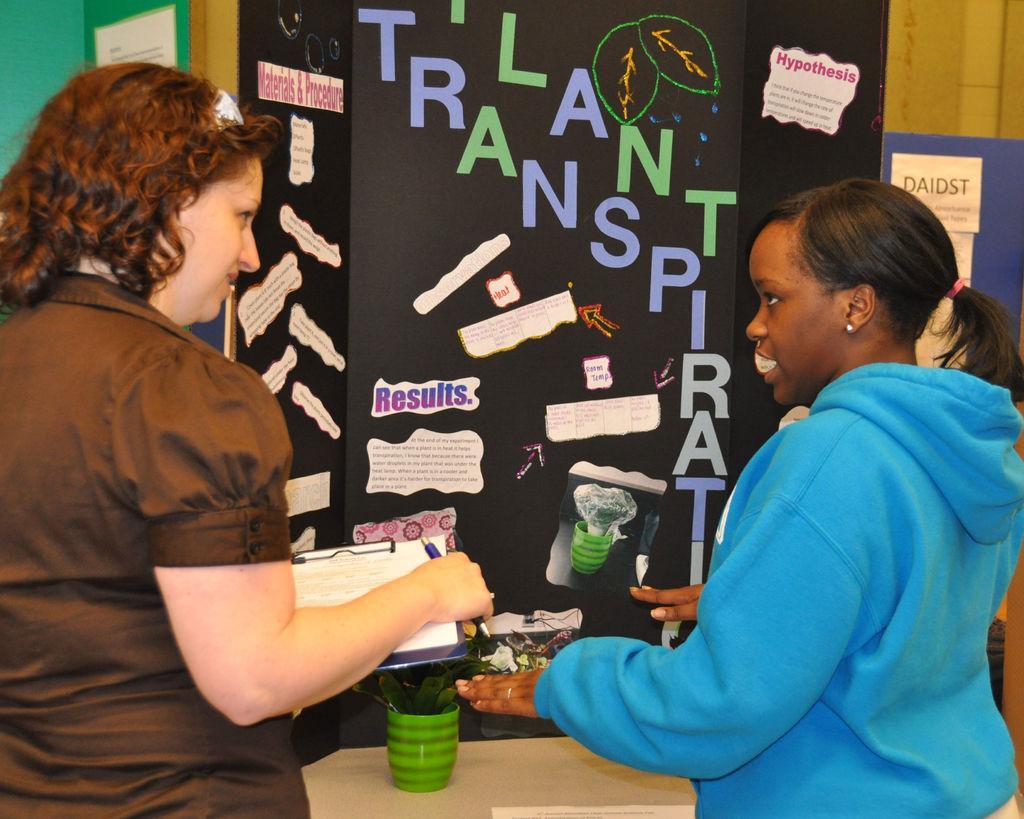In one or two sentences, can you explain what this image depicts? A woman is holding pad, paper and pen. There is another woman standing, there is a container, there are posters. 